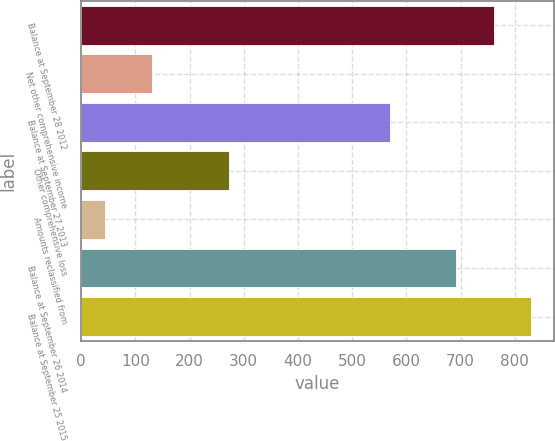Convert chart to OTSL. <chart><loc_0><loc_0><loc_500><loc_500><bar_chart><fcel>Balance at September 28 2012<fcel>Net other comprehensive income<fcel>Balance at September 27 2013<fcel>Other comprehensive loss<fcel>Amounts reclassified from<fcel>Balance at September 26 2014<fcel>Balance at September 25 2015<nl><fcel>761.4<fcel>131<fcel>569<fcel>273.4<fcel>44<fcel>692<fcel>830.8<nl></chart> 